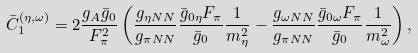Convert formula to latex. <formula><loc_0><loc_0><loc_500><loc_500>\bar { C } ^ { ( \eta , \omega ) } _ { 1 } = 2 \frac { g _ { A } \bar { g } _ { 0 } } { F ^ { 2 } _ { \pi } } \left ( \frac { g _ { \eta N N } } { g _ { \pi N N } } \frac { \bar { g } _ { 0 \eta } F _ { \pi } } { \bar { g } _ { 0 } } \frac { 1 } { m ^ { 2 } _ { \eta } } - \frac { g _ { \omega N N } } { g _ { \pi N N } } \frac { \bar { g } _ { 0 \omega } F _ { \pi } } { \bar { g } _ { 0 } } \frac { 1 } { m ^ { 2 } _ { \omega } } \right ) ,</formula> 